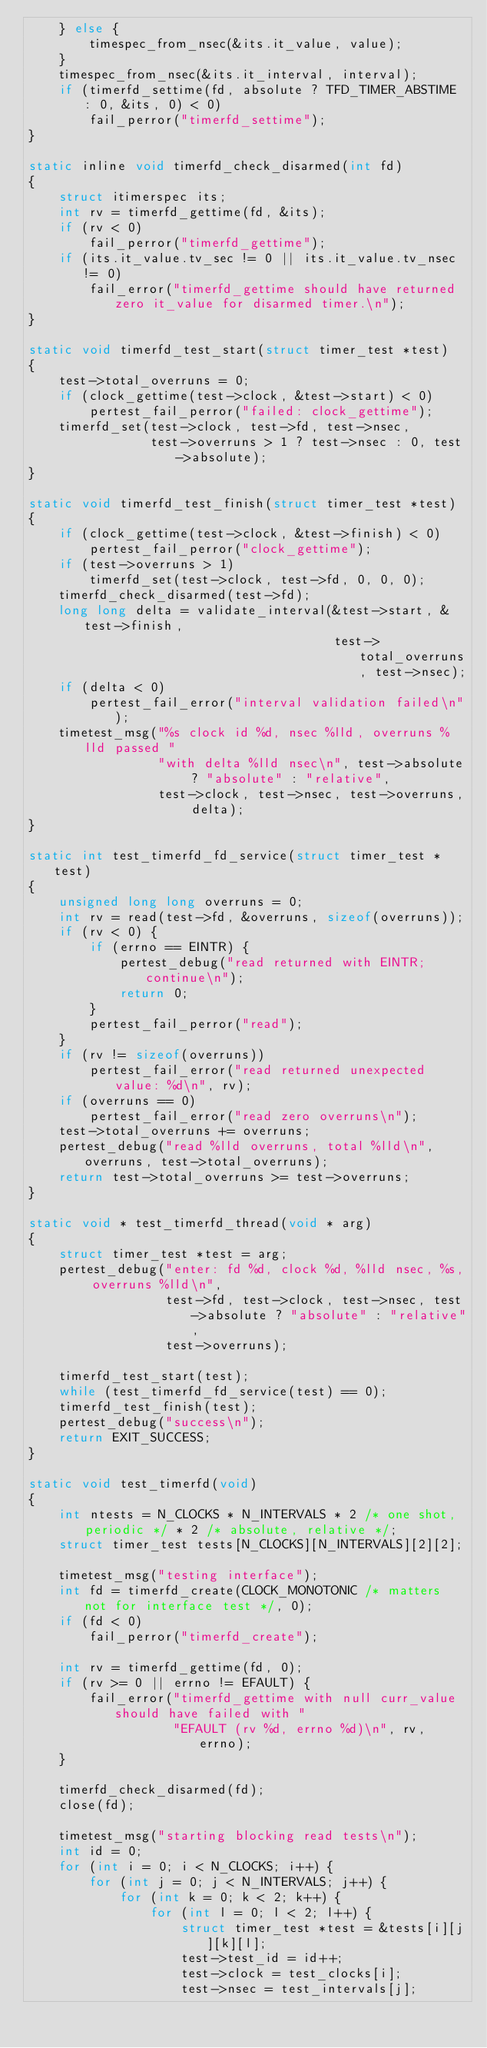<code> <loc_0><loc_0><loc_500><loc_500><_C_>    } else {
        timespec_from_nsec(&its.it_value, value);
    }
    timespec_from_nsec(&its.it_interval, interval);
    if (timerfd_settime(fd, absolute ? TFD_TIMER_ABSTIME : 0, &its, 0) < 0)
        fail_perror("timerfd_settime");
}

static inline void timerfd_check_disarmed(int fd)
{
    struct itimerspec its;
    int rv = timerfd_gettime(fd, &its);
    if (rv < 0)
        fail_perror("timerfd_gettime");
    if (its.it_value.tv_sec != 0 || its.it_value.tv_nsec != 0)
        fail_error("timerfd_gettime should have returned zero it_value for disarmed timer.\n");
}

static void timerfd_test_start(struct timer_test *test)
{
    test->total_overruns = 0;
    if (clock_gettime(test->clock, &test->start) < 0)
        pertest_fail_perror("failed: clock_gettime");
    timerfd_set(test->clock, test->fd, test->nsec,
                test->overruns > 1 ? test->nsec : 0, test->absolute);
}

static void timerfd_test_finish(struct timer_test *test)
{
    if (clock_gettime(test->clock, &test->finish) < 0)
        pertest_fail_perror("clock_gettime");
    if (test->overruns > 1)
        timerfd_set(test->clock, test->fd, 0, 0, 0);
    timerfd_check_disarmed(test->fd);
    long long delta = validate_interval(&test->start, &test->finish,
                                        test->total_overruns, test->nsec);
    if (delta < 0)
        pertest_fail_error("interval validation failed\n");
    timetest_msg("%s clock id %d, nsec %lld, overruns %lld passed "
                 "with delta %lld nsec\n", test->absolute ? "absolute" : "relative",
                 test->clock, test->nsec, test->overruns, delta);
}

static int test_timerfd_fd_service(struct timer_test *test)
{
    unsigned long long overruns = 0;
    int rv = read(test->fd, &overruns, sizeof(overruns));
    if (rv < 0) {
        if (errno == EINTR) {
            pertest_debug("read returned with EINTR; continue\n");
            return 0;
        }
        pertest_fail_perror("read");
    }
    if (rv != sizeof(overruns))
        pertest_fail_error("read returned unexpected value: %d\n", rv);
    if (overruns == 0)
        pertest_fail_error("read zero overruns\n");
    test->total_overruns += overruns;
    pertest_debug("read %lld overruns, total %lld\n", overruns, test->total_overruns);
    return test->total_overruns >= test->overruns;
}

static void * test_timerfd_thread(void * arg)
{
    struct timer_test *test = arg;
    pertest_debug("enter: fd %d, clock %d, %lld nsec, %s, overruns %lld\n",
                  test->fd, test->clock, test->nsec, test->absolute ? "absolute" : "relative",
                  test->overruns);

    timerfd_test_start(test);
    while (test_timerfd_fd_service(test) == 0);
    timerfd_test_finish(test);
    pertest_debug("success\n");
    return EXIT_SUCCESS;
}

static void test_timerfd(void)
{
    int ntests = N_CLOCKS * N_INTERVALS * 2 /* one shot, periodic */ * 2 /* absolute, relative */;
    struct timer_test tests[N_CLOCKS][N_INTERVALS][2][2];

    timetest_msg("testing interface");
    int fd = timerfd_create(CLOCK_MONOTONIC /* matters not for interface test */, 0);
    if (fd < 0)
        fail_perror("timerfd_create");

    int rv = timerfd_gettime(fd, 0);
    if (rv >= 0 || errno != EFAULT) {
        fail_error("timerfd_gettime with null curr_value should have failed with "
                   "EFAULT (rv %d, errno %d)\n", rv, errno);
    }

    timerfd_check_disarmed(fd);
    close(fd);

    timetest_msg("starting blocking read tests\n");
    int id = 0;
    for (int i = 0; i < N_CLOCKS; i++) {
        for (int j = 0; j < N_INTERVALS; j++) {
            for (int k = 0; k < 2; k++) {
                for (int l = 0; l < 2; l++) {
                    struct timer_test *test = &tests[i][j][k][l];
                    test->test_id = id++;
                    test->clock = test_clocks[i];
                    test->nsec = test_intervals[j];</code> 